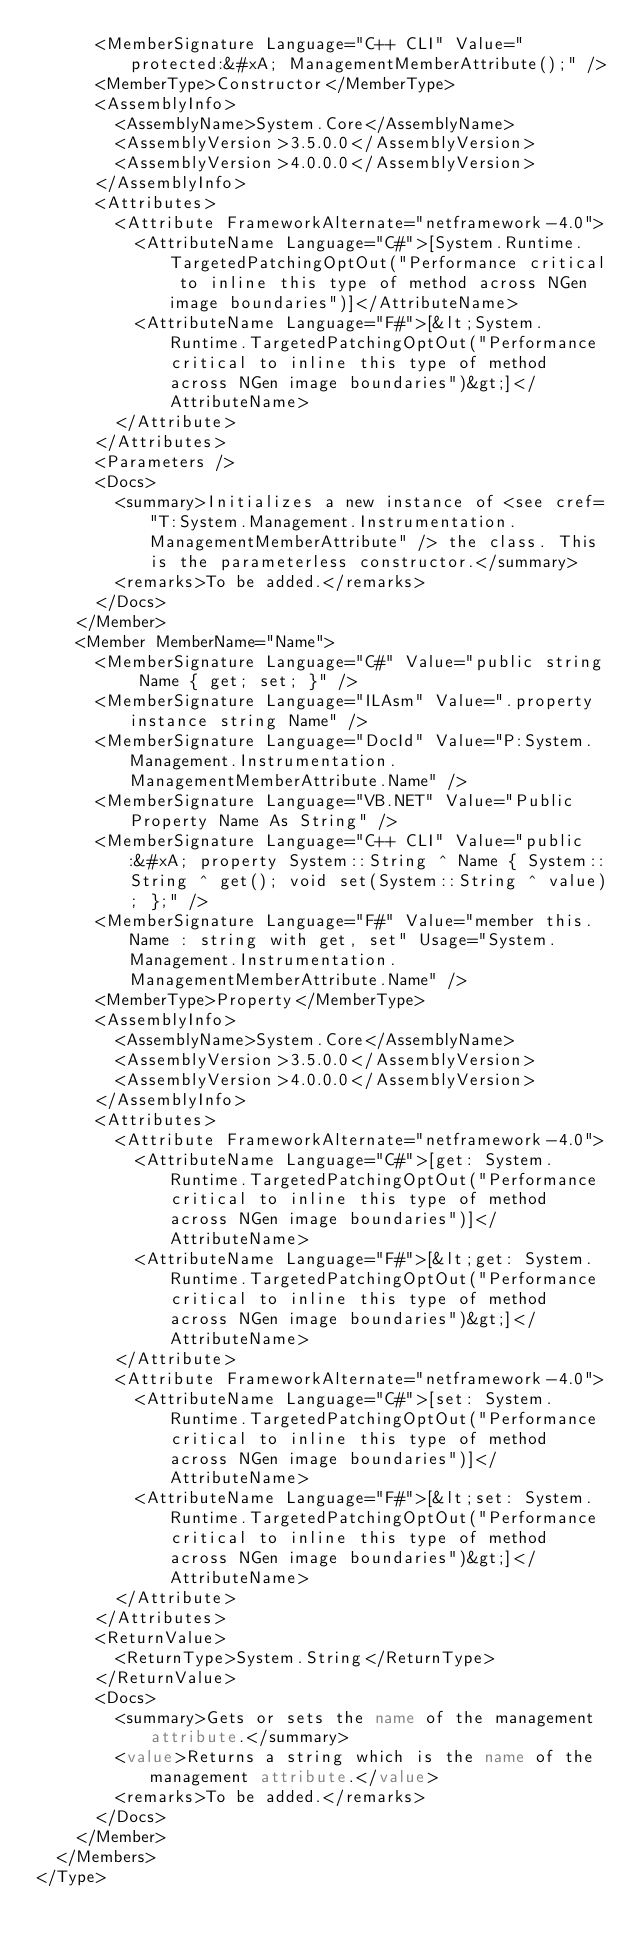<code> <loc_0><loc_0><loc_500><loc_500><_XML_>      <MemberSignature Language="C++ CLI" Value="protected:&#xA; ManagementMemberAttribute();" />
      <MemberType>Constructor</MemberType>
      <AssemblyInfo>
        <AssemblyName>System.Core</AssemblyName>
        <AssemblyVersion>3.5.0.0</AssemblyVersion>
        <AssemblyVersion>4.0.0.0</AssemblyVersion>
      </AssemblyInfo>
      <Attributes>
        <Attribute FrameworkAlternate="netframework-4.0">
          <AttributeName Language="C#">[System.Runtime.TargetedPatchingOptOut("Performance critical to inline this type of method across NGen image boundaries")]</AttributeName>
          <AttributeName Language="F#">[&lt;System.Runtime.TargetedPatchingOptOut("Performance critical to inline this type of method across NGen image boundaries")&gt;]</AttributeName>
        </Attribute>
      </Attributes>
      <Parameters />
      <Docs>
        <summary>Initializes a new instance of <see cref="T:System.Management.Instrumentation.ManagementMemberAttribute" /> the class. This is the parameterless constructor.</summary>
        <remarks>To be added.</remarks>
      </Docs>
    </Member>
    <Member MemberName="Name">
      <MemberSignature Language="C#" Value="public string Name { get; set; }" />
      <MemberSignature Language="ILAsm" Value=".property instance string Name" />
      <MemberSignature Language="DocId" Value="P:System.Management.Instrumentation.ManagementMemberAttribute.Name" />
      <MemberSignature Language="VB.NET" Value="Public Property Name As String" />
      <MemberSignature Language="C++ CLI" Value="public:&#xA; property System::String ^ Name { System::String ^ get(); void set(System::String ^ value); };" />
      <MemberSignature Language="F#" Value="member this.Name : string with get, set" Usage="System.Management.Instrumentation.ManagementMemberAttribute.Name" />
      <MemberType>Property</MemberType>
      <AssemblyInfo>
        <AssemblyName>System.Core</AssemblyName>
        <AssemblyVersion>3.5.0.0</AssemblyVersion>
        <AssemblyVersion>4.0.0.0</AssemblyVersion>
      </AssemblyInfo>
      <Attributes>
        <Attribute FrameworkAlternate="netframework-4.0">
          <AttributeName Language="C#">[get: System.Runtime.TargetedPatchingOptOut("Performance critical to inline this type of method across NGen image boundaries")]</AttributeName>
          <AttributeName Language="F#">[&lt;get: System.Runtime.TargetedPatchingOptOut("Performance critical to inline this type of method across NGen image boundaries")&gt;]</AttributeName>
        </Attribute>
        <Attribute FrameworkAlternate="netframework-4.0">
          <AttributeName Language="C#">[set: System.Runtime.TargetedPatchingOptOut("Performance critical to inline this type of method across NGen image boundaries")]</AttributeName>
          <AttributeName Language="F#">[&lt;set: System.Runtime.TargetedPatchingOptOut("Performance critical to inline this type of method across NGen image boundaries")&gt;]</AttributeName>
        </Attribute>
      </Attributes>
      <ReturnValue>
        <ReturnType>System.String</ReturnType>
      </ReturnValue>
      <Docs>
        <summary>Gets or sets the name of the management attribute.</summary>
        <value>Returns a string which is the name of the management attribute.</value>
        <remarks>To be added.</remarks>
      </Docs>
    </Member>
  </Members>
</Type>
</code> 